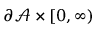<formula> <loc_0><loc_0><loc_500><loc_500>\partial \mathcal { A } \times [ 0 , \infty )</formula> 